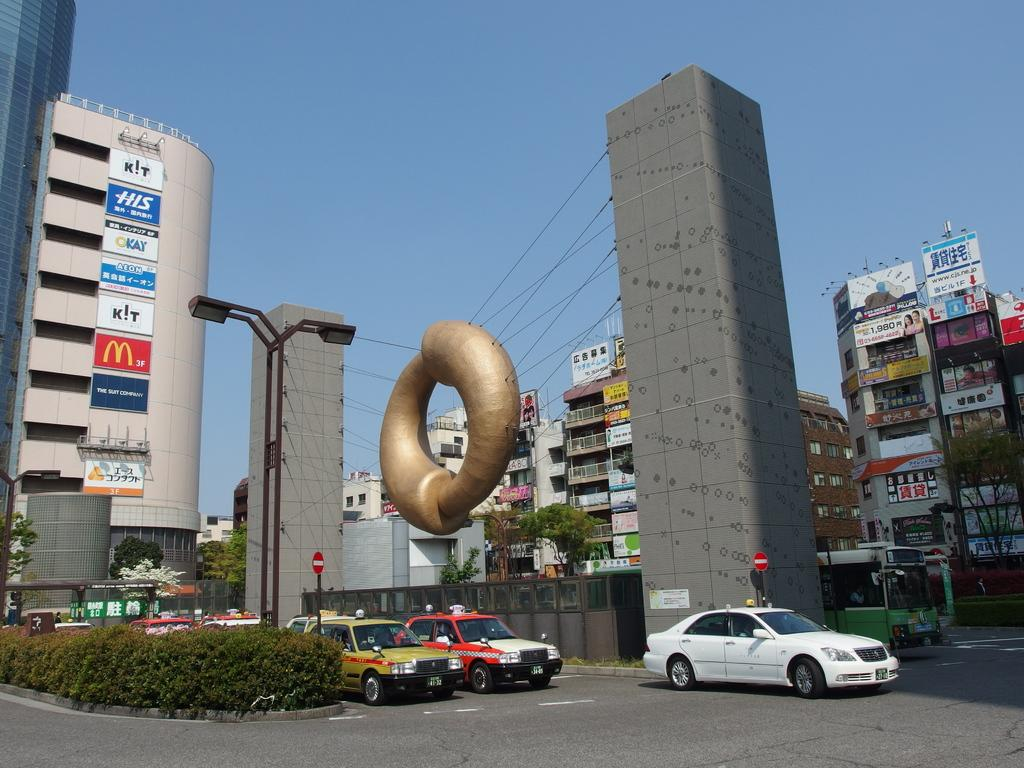<image>
Summarize the visual content of the image. A city street has cars waiting to enter an intersection and a sign that says Okay. 